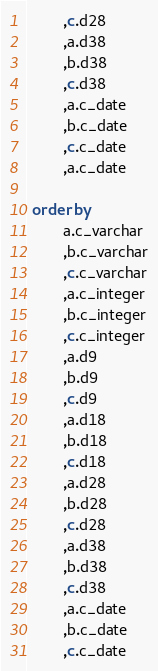<code> <loc_0><loc_0><loc_500><loc_500><_SQL_> 		,c.d28
 		,a.d38
 		,b.d38
 		,c.d38
 		,a.c_date
 		,b.c_date
 		,c.c_date
 		,a.c_date

 order by
  		a.c_varchar
 		,b.c_varchar
 		,c.c_varchar
 		,a.c_integer
 		,b.c_integer
 		,c.c_integer
 		,a.d9
 		,b.d9
 		,c.d9
 		,a.d18
 		,b.d18
 		,c.d18
 		,a.d28
 		,b.d28
 		,c.d28
 		,a.d38
 		,b.d38
 		,c.d38
 		,a.c_date
 		,b.c_date
 		,c.c_date</code> 